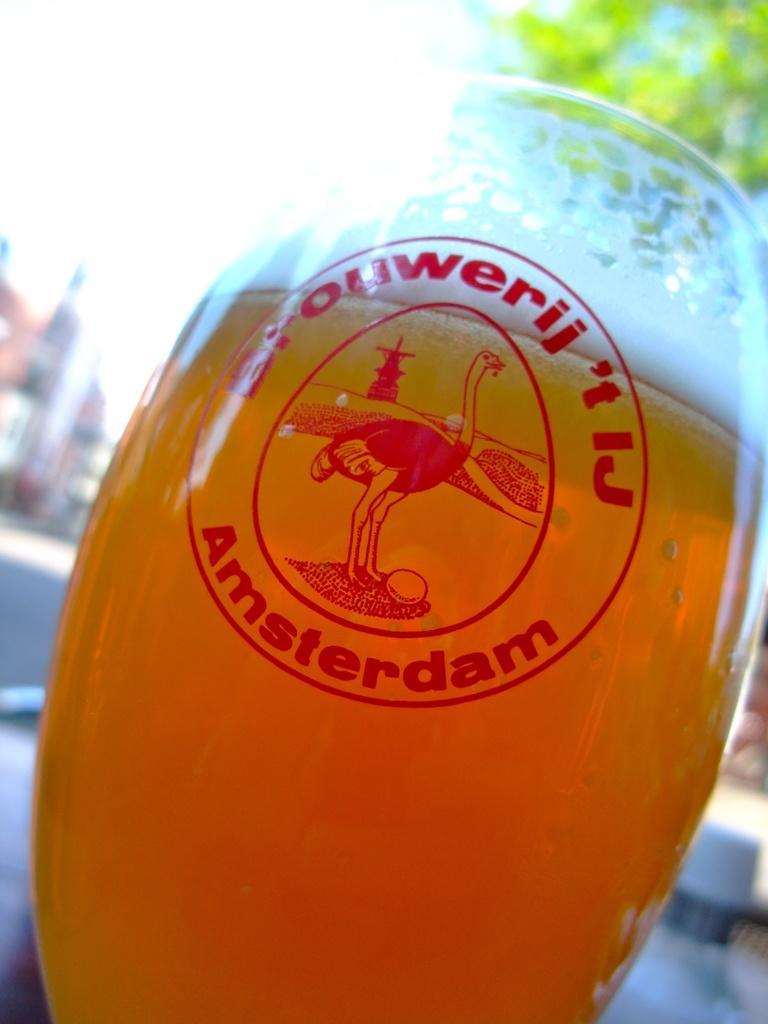Please provide a concise description of this image. In this image I can see a wine glass with orange colored liquid in it. In the background I can see the road, few buildings, the sky and a tree. 